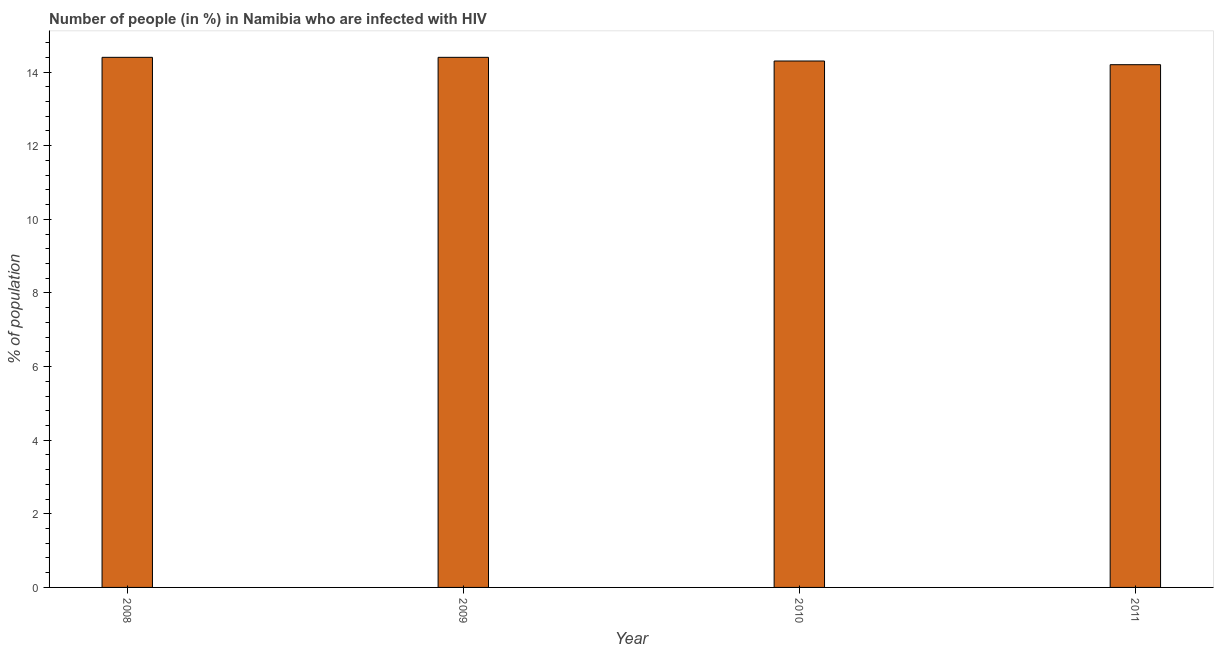Does the graph contain any zero values?
Provide a succinct answer. No. What is the title of the graph?
Your answer should be very brief. Number of people (in %) in Namibia who are infected with HIV. What is the label or title of the X-axis?
Provide a succinct answer. Year. What is the label or title of the Y-axis?
Your answer should be very brief. % of population. Across all years, what is the maximum number of people infected with hiv?
Keep it short and to the point. 14.4. Across all years, what is the minimum number of people infected with hiv?
Provide a succinct answer. 14.2. In which year was the number of people infected with hiv maximum?
Offer a very short reply. 2008. In which year was the number of people infected with hiv minimum?
Your answer should be very brief. 2011. What is the sum of the number of people infected with hiv?
Provide a succinct answer. 57.3. What is the average number of people infected with hiv per year?
Provide a succinct answer. 14.32. What is the median number of people infected with hiv?
Make the answer very short. 14.35. What is the ratio of the number of people infected with hiv in 2008 to that in 2009?
Keep it short and to the point. 1. What is the difference between the highest and the second highest number of people infected with hiv?
Provide a succinct answer. 0. Is the sum of the number of people infected with hiv in 2010 and 2011 greater than the maximum number of people infected with hiv across all years?
Ensure brevity in your answer.  Yes. How many bars are there?
Keep it short and to the point. 4. What is the % of population in 2008?
Your response must be concise. 14.4. What is the difference between the % of population in 2008 and 2009?
Offer a terse response. 0. What is the difference between the % of population in 2008 and 2010?
Give a very brief answer. 0.1. What is the difference between the % of population in 2008 and 2011?
Give a very brief answer. 0.2. What is the difference between the % of population in 2009 and 2010?
Offer a terse response. 0.1. What is the ratio of the % of population in 2008 to that in 2009?
Make the answer very short. 1. What is the ratio of the % of population in 2009 to that in 2010?
Give a very brief answer. 1.01. What is the ratio of the % of population in 2010 to that in 2011?
Your response must be concise. 1.01. 